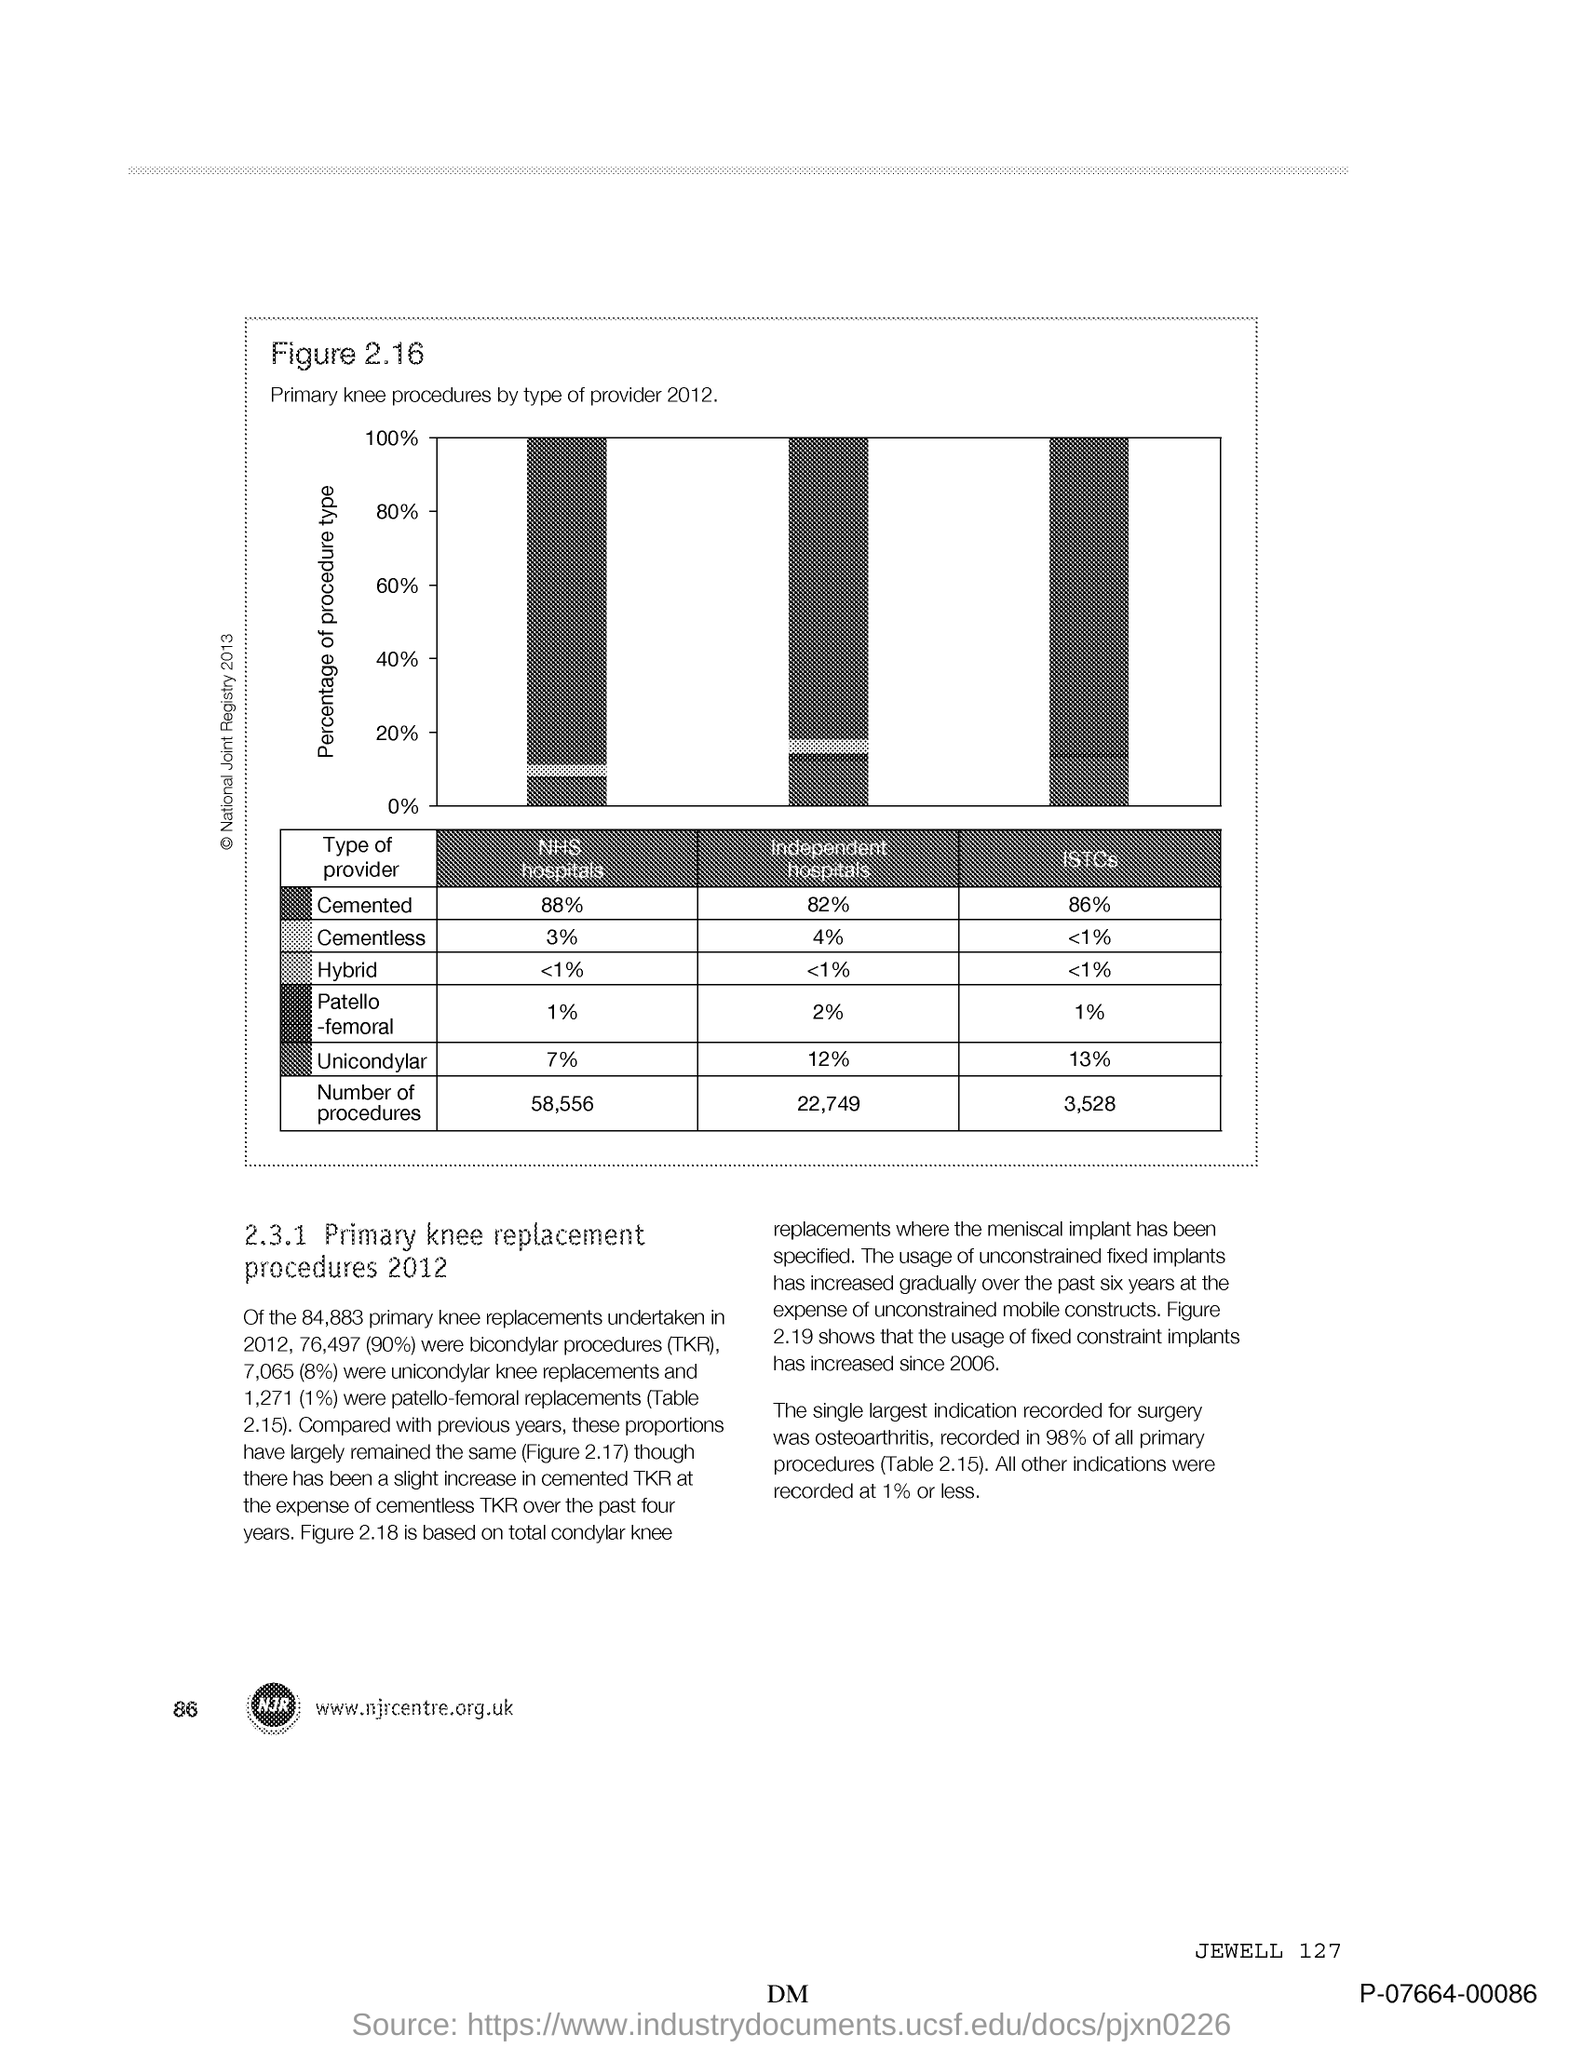What is plotted in the y-axis?
Provide a short and direct response. Percentage of procedure type. What is the Page Number?
Your answer should be very brief. 86. 